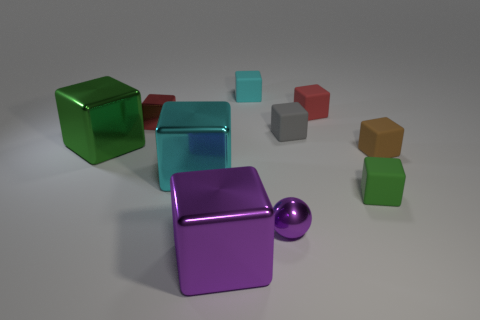How would you describe the overall composition of the shapes and colors in this image? The image presents a pleasing variety of geometric shapes, including cubes and a sphere, arranged asymmetrically. The colors are rich and diverse, ranging from muted to vibrant tones, which creates a dynamic contrast and adds visual interest to the composition. 